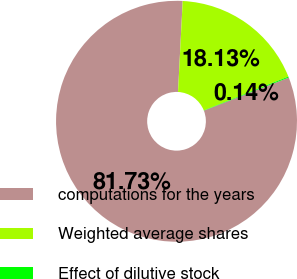<chart> <loc_0><loc_0><loc_500><loc_500><pie_chart><fcel>computations for the years<fcel>Weighted average shares<fcel>Effect of dilutive stock<nl><fcel>81.73%<fcel>18.13%<fcel>0.14%<nl></chart> 